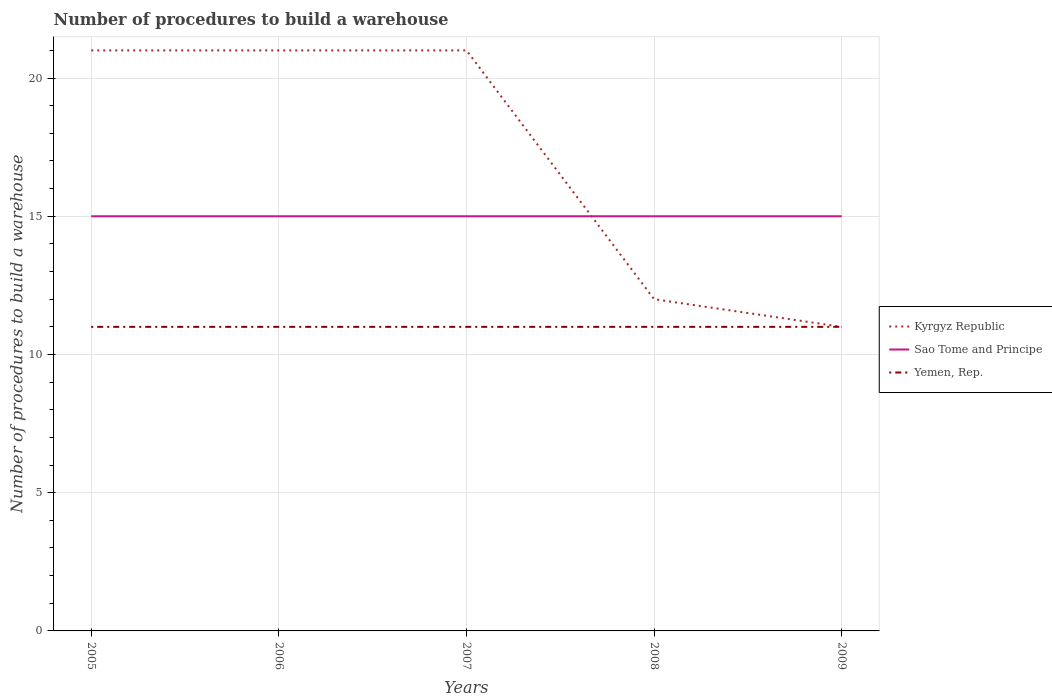Does the line corresponding to Yemen, Rep. intersect with the line corresponding to Kyrgyz Republic?
Provide a succinct answer. Yes. Across all years, what is the maximum number of procedures to build a warehouse in in Kyrgyz Republic?
Ensure brevity in your answer.  11. What is the difference between the highest and the second highest number of procedures to build a warehouse in in Yemen, Rep.?
Provide a succinct answer. 0. Is the number of procedures to build a warehouse in in Yemen, Rep. strictly greater than the number of procedures to build a warehouse in in Sao Tome and Principe over the years?
Make the answer very short. Yes. What is the difference between two consecutive major ticks on the Y-axis?
Provide a short and direct response. 5. Does the graph contain any zero values?
Keep it short and to the point. No. How are the legend labels stacked?
Keep it short and to the point. Vertical. What is the title of the graph?
Your response must be concise. Number of procedures to build a warehouse. What is the label or title of the Y-axis?
Provide a succinct answer. Number of procedures to build a warehouse. What is the Number of procedures to build a warehouse in Yemen, Rep. in 2005?
Offer a terse response. 11. What is the Number of procedures to build a warehouse of Kyrgyz Republic in 2006?
Your answer should be very brief. 21. What is the Number of procedures to build a warehouse of Sao Tome and Principe in 2007?
Provide a short and direct response. 15. What is the Number of procedures to build a warehouse of Yemen, Rep. in 2007?
Provide a short and direct response. 11. What is the Number of procedures to build a warehouse in Sao Tome and Principe in 2008?
Keep it short and to the point. 15. What is the Number of procedures to build a warehouse in Kyrgyz Republic in 2009?
Make the answer very short. 11. Across all years, what is the maximum Number of procedures to build a warehouse of Sao Tome and Principe?
Provide a short and direct response. 15. Across all years, what is the minimum Number of procedures to build a warehouse of Sao Tome and Principe?
Ensure brevity in your answer.  15. Across all years, what is the minimum Number of procedures to build a warehouse of Yemen, Rep.?
Offer a terse response. 11. What is the difference between the Number of procedures to build a warehouse of Kyrgyz Republic in 2005 and that in 2006?
Provide a short and direct response. 0. What is the difference between the Number of procedures to build a warehouse in Sao Tome and Principe in 2005 and that in 2006?
Your answer should be very brief. 0. What is the difference between the Number of procedures to build a warehouse in Yemen, Rep. in 2005 and that in 2006?
Make the answer very short. 0. What is the difference between the Number of procedures to build a warehouse in Kyrgyz Republic in 2005 and that in 2007?
Give a very brief answer. 0. What is the difference between the Number of procedures to build a warehouse of Sao Tome and Principe in 2005 and that in 2007?
Your answer should be compact. 0. What is the difference between the Number of procedures to build a warehouse of Yemen, Rep. in 2005 and that in 2007?
Keep it short and to the point. 0. What is the difference between the Number of procedures to build a warehouse of Sao Tome and Principe in 2005 and that in 2008?
Your answer should be very brief. 0. What is the difference between the Number of procedures to build a warehouse of Yemen, Rep. in 2005 and that in 2008?
Ensure brevity in your answer.  0. What is the difference between the Number of procedures to build a warehouse in Kyrgyz Republic in 2005 and that in 2009?
Provide a short and direct response. 10. What is the difference between the Number of procedures to build a warehouse in Sao Tome and Principe in 2005 and that in 2009?
Ensure brevity in your answer.  0. What is the difference between the Number of procedures to build a warehouse of Yemen, Rep. in 2005 and that in 2009?
Keep it short and to the point. 0. What is the difference between the Number of procedures to build a warehouse of Kyrgyz Republic in 2006 and that in 2007?
Keep it short and to the point. 0. What is the difference between the Number of procedures to build a warehouse of Sao Tome and Principe in 2006 and that in 2007?
Your answer should be very brief. 0. What is the difference between the Number of procedures to build a warehouse in Yemen, Rep. in 2006 and that in 2007?
Make the answer very short. 0. What is the difference between the Number of procedures to build a warehouse of Kyrgyz Republic in 2006 and that in 2008?
Keep it short and to the point. 9. What is the difference between the Number of procedures to build a warehouse in Yemen, Rep. in 2006 and that in 2008?
Your response must be concise. 0. What is the difference between the Number of procedures to build a warehouse in Yemen, Rep. in 2006 and that in 2009?
Provide a short and direct response. 0. What is the difference between the Number of procedures to build a warehouse in Yemen, Rep. in 2007 and that in 2008?
Offer a terse response. 0. What is the difference between the Number of procedures to build a warehouse in Kyrgyz Republic in 2007 and that in 2009?
Offer a very short reply. 10. What is the difference between the Number of procedures to build a warehouse in Sao Tome and Principe in 2007 and that in 2009?
Give a very brief answer. 0. What is the difference between the Number of procedures to build a warehouse in Yemen, Rep. in 2007 and that in 2009?
Ensure brevity in your answer.  0. What is the difference between the Number of procedures to build a warehouse of Yemen, Rep. in 2008 and that in 2009?
Provide a succinct answer. 0. What is the difference between the Number of procedures to build a warehouse of Kyrgyz Republic in 2005 and the Number of procedures to build a warehouse of Yemen, Rep. in 2007?
Your response must be concise. 10. What is the difference between the Number of procedures to build a warehouse in Sao Tome and Principe in 2005 and the Number of procedures to build a warehouse in Yemen, Rep. in 2007?
Your answer should be compact. 4. What is the difference between the Number of procedures to build a warehouse in Kyrgyz Republic in 2005 and the Number of procedures to build a warehouse in Yemen, Rep. in 2008?
Your answer should be very brief. 10. What is the difference between the Number of procedures to build a warehouse of Kyrgyz Republic in 2005 and the Number of procedures to build a warehouse of Sao Tome and Principe in 2009?
Offer a terse response. 6. What is the difference between the Number of procedures to build a warehouse in Kyrgyz Republic in 2006 and the Number of procedures to build a warehouse in Yemen, Rep. in 2007?
Offer a very short reply. 10. What is the difference between the Number of procedures to build a warehouse of Sao Tome and Principe in 2006 and the Number of procedures to build a warehouse of Yemen, Rep. in 2007?
Offer a terse response. 4. What is the difference between the Number of procedures to build a warehouse in Sao Tome and Principe in 2006 and the Number of procedures to build a warehouse in Yemen, Rep. in 2008?
Offer a very short reply. 4. What is the difference between the Number of procedures to build a warehouse in Kyrgyz Republic in 2006 and the Number of procedures to build a warehouse in Yemen, Rep. in 2009?
Offer a terse response. 10. What is the difference between the Number of procedures to build a warehouse of Sao Tome and Principe in 2006 and the Number of procedures to build a warehouse of Yemen, Rep. in 2009?
Your response must be concise. 4. What is the difference between the Number of procedures to build a warehouse of Kyrgyz Republic in 2007 and the Number of procedures to build a warehouse of Yemen, Rep. in 2008?
Your answer should be very brief. 10. What is the difference between the Number of procedures to build a warehouse of Kyrgyz Republic in 2007 and the Number of procedures to build a warehouse of Sao Tome and Principe in 2009?
Provide a succinct answer. 6. What is the difference between the Number of procedures to build a warehouse of Kyrgyz Republic in 2007 and the Number of procedures to build a warehouse of Yemen, Rep. in 2009?
Your response must be concise. 10. What is the difference between the Number of procedures to build a warehouse in Sao Tome and Principe in 2007 and the Number of procedures to build a warehouse in Yemen, Rep. in 2009?
Your response must be concise. 4. What is the difference between the Number of procedures to build a warehouse of Kyrgyz Republic in 2008 and the Number of procedures to build a warehouse of Sao Tome and Principe in 2009?
Make the answer very short. -3. What is the difference between the Number of procedures to build a warehouse in Sao Tome and Principe in 2008 and the Number of procedures to build a warehouse in Yemen, Rep. in 2009?
Provide a succinct answer. 4. What is the average Number of procedures to build a warehouse in Sao Tome and Principe per year?
Your answer should be compact. 15. What is the average Number of procedures to build a warehouse of Yemen, Rep. per year?
Your response must be concise. 11. In the year 2005, what is the difference between the Number of procedures to build a warehouse in Sao Tome and Principe and Number of procedures to build a warehouse in Yemen, Rep.?
Offer a terse response. 4. In the year 2007, what is the difference between the Number of procedures to build a warehouse of Sao Tome and Principe and Number of procedures to build a warehouse of Yemen, Rep.?
Give a very brief answer. 4. In the year 2008, what is the difference between the Number of procedures to build a warehouse in Kyrgyz Republic and Number of procedures to build a warehouse in Sao Tome and Principe?
Keep it short and to the point. -3. In the year 2008, what is the difference between the Number of procedures to build a warehouse in Kyrgyz Republic and Number of procedures to build a warehouse in Yemen, Rep.?
Offer a very short reply. 1. In the year 2008, what is the difference between the Number of procedures to build a warehouse of Sao Tome and Principe and Number of procedures to build a warehouse of Yemen, Rep.?
Give a very brief answer. 4. What is the ratio of the Number of procedures to build a warehouse in Kyrgyz Republic in 2005 to that in 2006?
Provide a succinct answer. 1. What is the ratio of the Number of procedures to build a warehouse of Sao Tome and Principe in 2005 to that in 2006?
Ensure brevity in your answer.  1. What is the ratio of the Number of procedures to build a warehouse of Yemen, Rep. in 2005 to that in 2007?
Your answer should be very brief. 1. What is the ratio of the Number of procedures to build a warehouse in Sao Tome and Principe in 2005 to that in 2008?
Provide a succinct answer. 1. What is the ratio of the Number of procedures to build a warehouse of Yemen, Rep. in 2005 to that in 2008?
Make the answer very short. 1. What is the ratio of the Number of procedures to build a warehouse of Kyrgyz Republic in 2005 to that in 2009?
Ensure brevity in your answer.  1.91. What is the ratio of the Number of procedures to build a warehouse in Sao Tome and Principe in 2005 to that in 2009?
Make the answer very short. 1. What is the ratio of the Number of procedures to build a warehouse of Kyrgyz Republic in 2006 to that in 2007?
Ensure brevity in your answer.  1. What is the ratio of the Number of procedures to build a warehouse of Kyrgyz Republic in 2006 to that in 2008?
Give a very brief answer. 1.75. What is the ratio of the Number of procedures to build a warehouse in Yemen, Rep. in 2006 to that in 2008?
Offer a very short reply. 1. What is the ratio of the Number of procedures to build a warehouse in Kyrgyz Republic in 2006 to that in 2009?
Ensure brevity in your answer.  1.91. What is the ratio of the Number of procedures to build a warehouse of Sao Tome and Principe in 2007 to that in 2008?
Give a very brief answer. 1. What is the ratio of the Number of procedures to build a warehouse of Yemen, Rep. in 2007 to that in 2008?
Ensure brevity in your answer.  1. What is the ratio of the Number of procedures to build a warehouse of Kyrgyz Republic in 2007 to that in 2009?
Your answer should be compact. 1.91. What is the ratio of the Number of procedures to build a warehouse of Sao Tome and Principe in 2007 to that in 2009?
Make the answer very short. 1. What is the ratio of the Number of procedures to build a warehouse in Yemen, Rep. in 2007 to that in 2009?
Offer a very short reply. 1. What is the ratio of the Number of procedures to build a warehouse in Sao Tome and Principe in 2008 to that in 2009?
Offer a terse response. 1. What is the ratio of the Number of procedures to build a warehouse of Yemen, Rep. in 2008 to that in 2009?
Keep it short and to the point. 1. What is the difference between the highest and the second highest Number of procedures to build a warehouse in Kyrgyz Republic?
Give a very brief answer. 0. What is the difference between the highest and the lowest Number of procedures to build a warehouse in Kyrgyz Republic?
Ensure brevity in your answer.  10. What is the difference between the highest and the lowest Number of procedures to build a warehouse of Sao Tome and Principe?
Offer a very short reply. 0. What is the difference between the highest and the lowest Number of procedures to build a warehouse in Yemen, Rep.?
Your response must be concise. 0. 